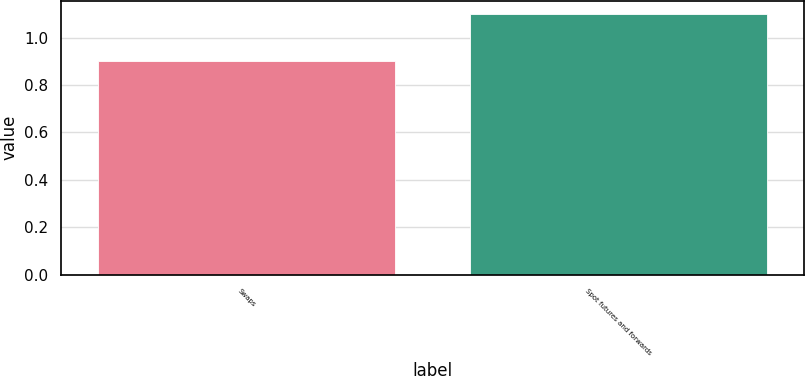<chart> <loc_0><loc_0><loc_500><loc_500><bar_chart><fcel>Swaps<fcel>Spot futures and forwards<nl><fcel>0.9<fcel>1.1<nl></chart> 